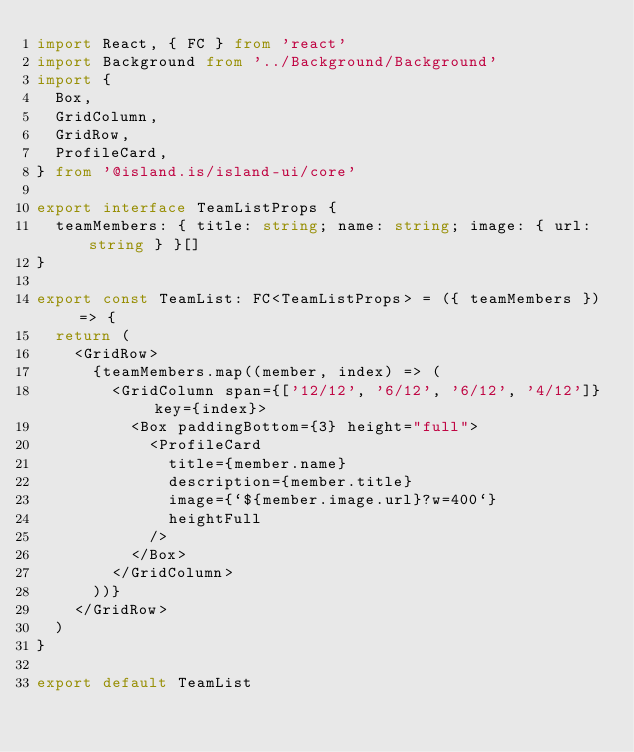<code> <loc_0><loc_0><loc_500><loc_500><_TypeScript_>import React, { FC } from 'react'
import Background from '../Background/Background'
import {
  Box,
  GridColumn,
  GridRow,
  ProfileCard,
} from '@island.is/island-ui/core'

export interface TeamListProps {
  teamMembers: { title: string; name: string; image: { url: string } }[]
}

export const TeamList: FC<TeamListProps> = ({ teamMembers }) => {
  return (
    <GridRow>
      {teamMembers.map((member, index) => (
        <GridColumn span={['12/12', '6/12', '6/12', '4/12']} key={index}>
          <Box paddingBottom={3} height="full">
            <ProfileCard
              title={member.name}
              description={member.title}
              image={`${member.image.url}?w=400`}
              heightFull
            />
          </Box>
        </GridColumn>
      ))}
    </GridRow>
  )
}

export default TeamList
</code> 